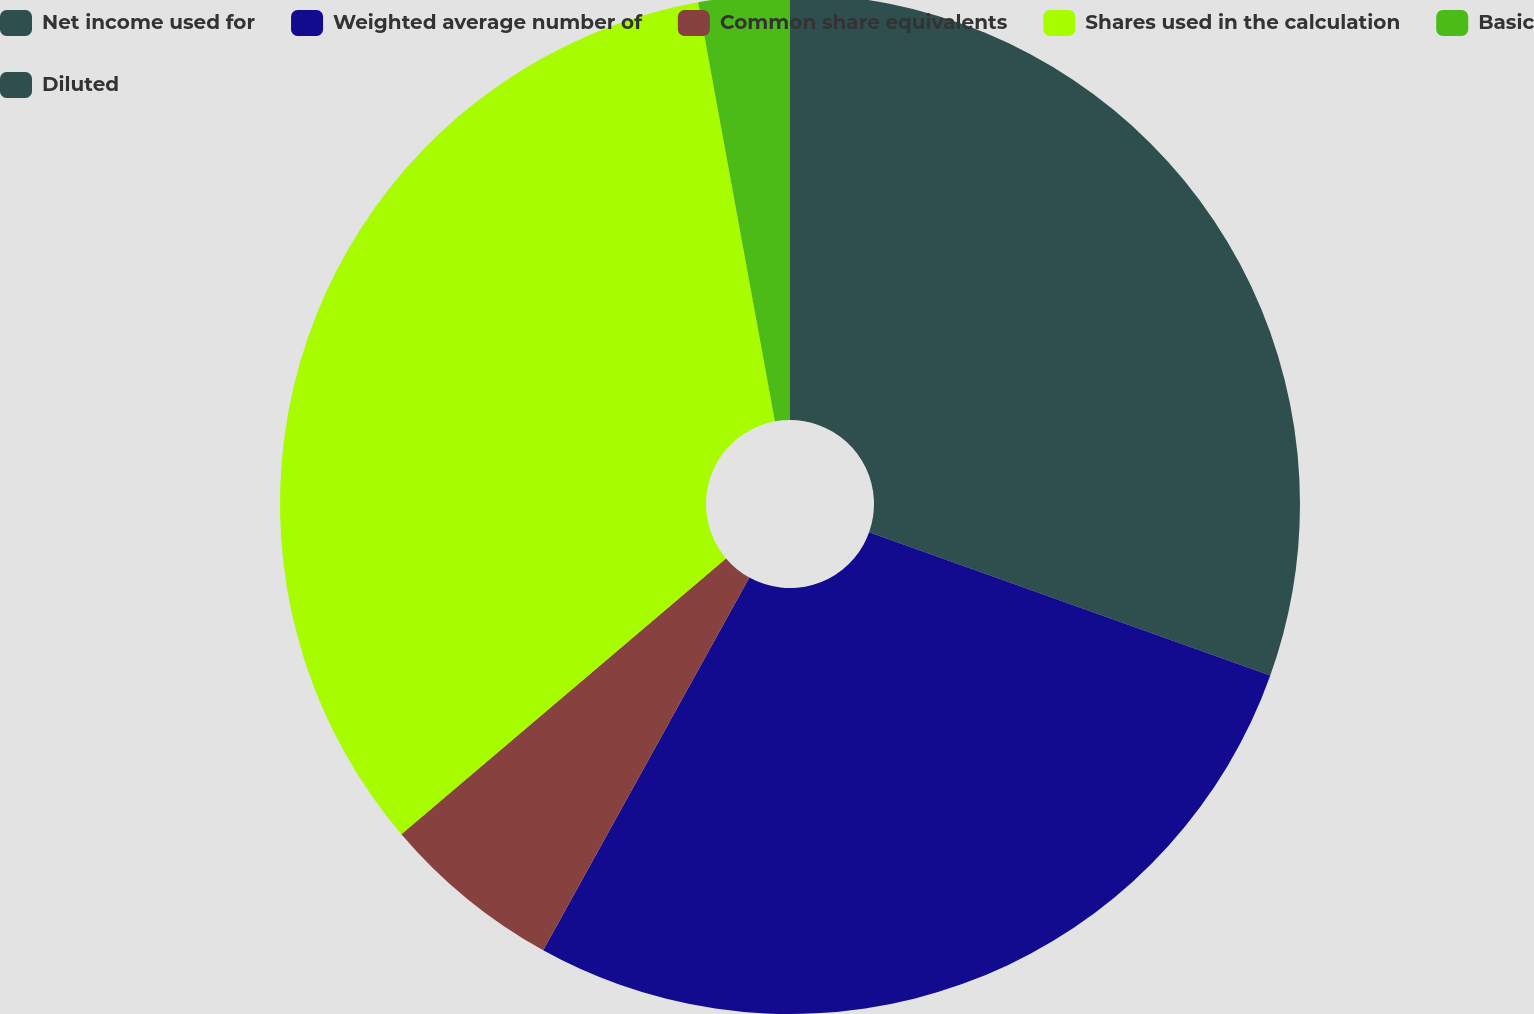Convert chart. <chart><loc_0><loc_0><loc_500><loc_500><pie_chart><fcel>Net income used for<fcel>Weighted average number of<fcel>Common share equivalents<fcel>Shares used in the calculation<fcel>Basic<fcel>Diluted<nl><fcel>30.46%<fcel>27.58%<fcel>5.75%<fcel>33.33%<fcel>2.88%<fcel>0.0%<nl></chart> 